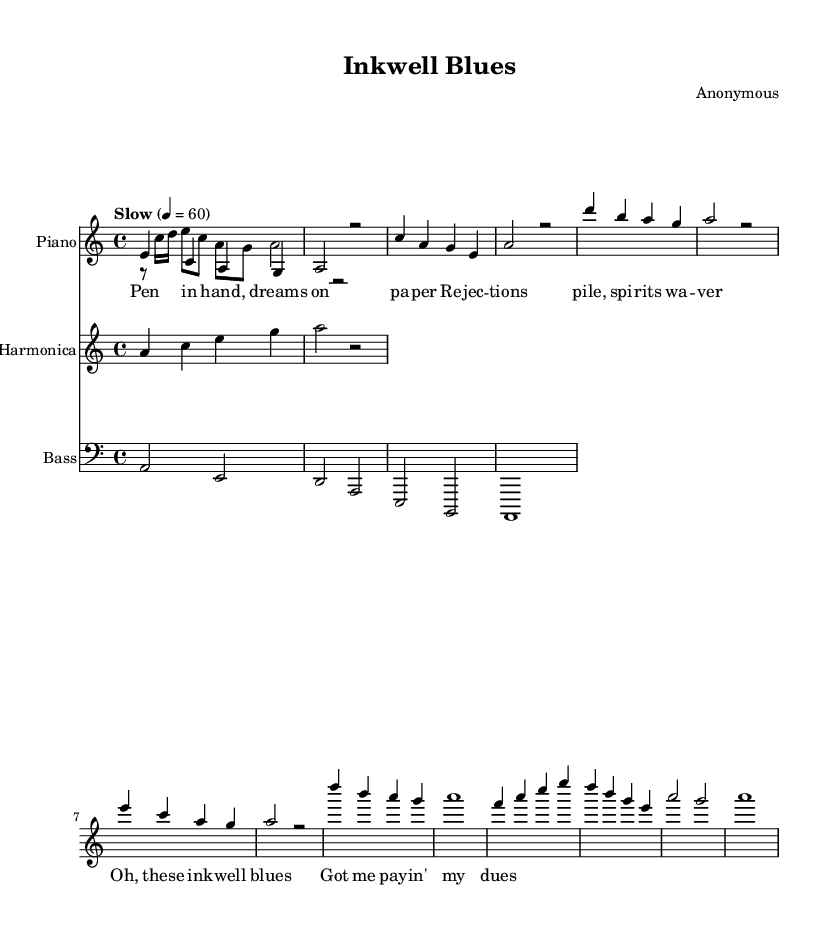What is the key signature of this music? The key signature is A minor, as indicated by the absence of sharps and flats in the staff. A minor is the relative minor of C major.
Answer: A minor What is the time signature of this music? The time signature is indicated at the beginning of the staff, shown as 4/4, which means there are four beats in each measure and a quarter note receives one beat.
Answer: 4/4 What is the tempo marking for this piece? The tempo marking “Slow” is written above the staff, indicating a slower performance speed. The number 60 refers to the beats per minute, reinforcing that it should be played slowly.
Answer: Slow How many measures are there in the verse? By counting the measures in the section labeled as "Verse" from the sheet music, there are four measures, each containing various notes.
Answer: 4 What instruments are used in this piece? The instruments are listed at the beginning of each staff: Piano, Harmonica, and Bass, indicating the ensemble required for performance.
Answer: Piano, Harmonica, Bass What lyrical theme is presented in the chorus? The lyrics in the chorus express a feeling of struggle and hardship, as indicated by phrases like “these ink well blues” and “paying my dues,” which relate to the author's journey in writing.
Answer: Struggle What is the main musical feature of the "Blues" genre seen here? The main feature of the Blues genre evident in this piece is the use of a twelve-bar structure, common in blues compositions, which affects the harmonic progression and lyrical themes surrounding hardship and emotion.
Answer: Twelve-bar structure 